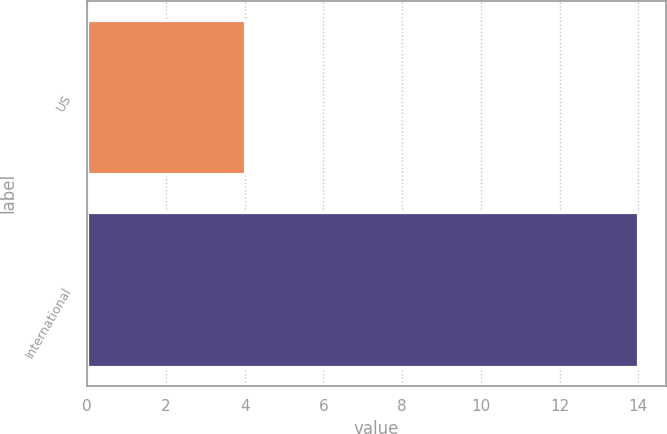<chart> <loc_0><loc_0><loc_500><loc_500><bar_chart><fcel>US<fcel>International<nl><fcel>4<fcel>14<nl></chart> 